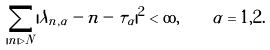<formula> <loc_0><loc_0><loc_500><loc_500>\sum _ { | n | > N } | \lambda _ { n , \alpha } - n - \tau _ { \alpha } | ^ { 2 } < \infty , \quad \alpha = 1 , 2 .</formula> 